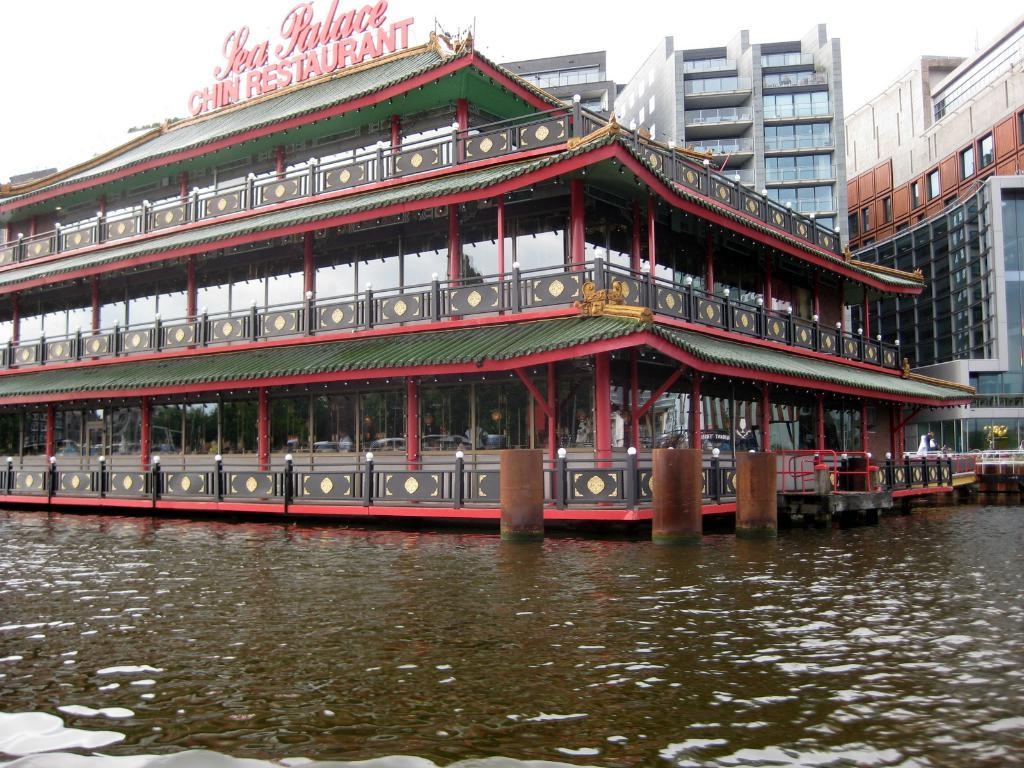What type of establishment is shown in the image? There is a restaurant in the image. What can be seen on the restaurant? There is text on the restaurant. What other structures are visible in the image? There are buildings visible in the image. What natural element is visible in the image? There is water visible in the image. What is visible above the buildings and water? The sky is visible in the image. How many apples are being placed in the basket in the image? There is no basket or apple present in the image. What type of attention is the restaurant receiving in the image? The image does not show any indication of the restaurant receiving attention; it simply depicts the restaurant and its surroundings. 